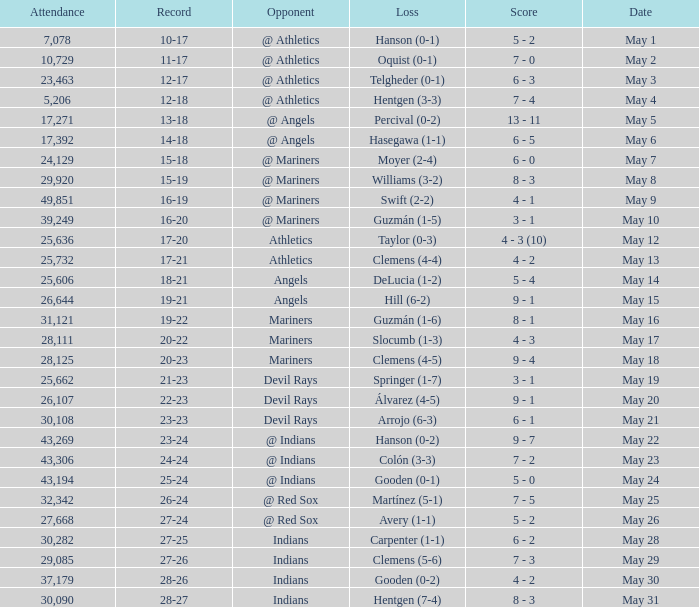What is the record for May 31? 28-27. 